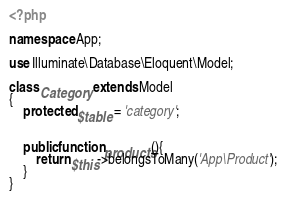Convert code to text. <code><loc_0><loc_0><loc_500><loc_500><_PHP_><?php

namespace App;

use Illuminate\Database\Eloquent\Model;

class Category extends Model
{
	protected $table = 'category';


    public function products(){
    	return $this->belongsToMany('App\Product');
    }
}
</code> 